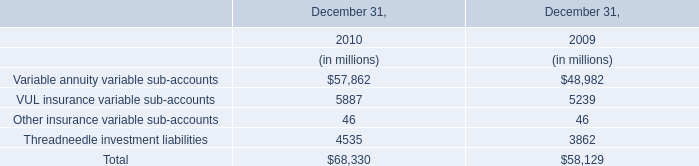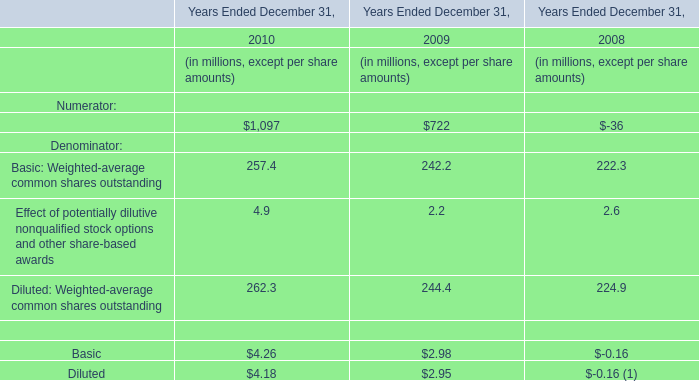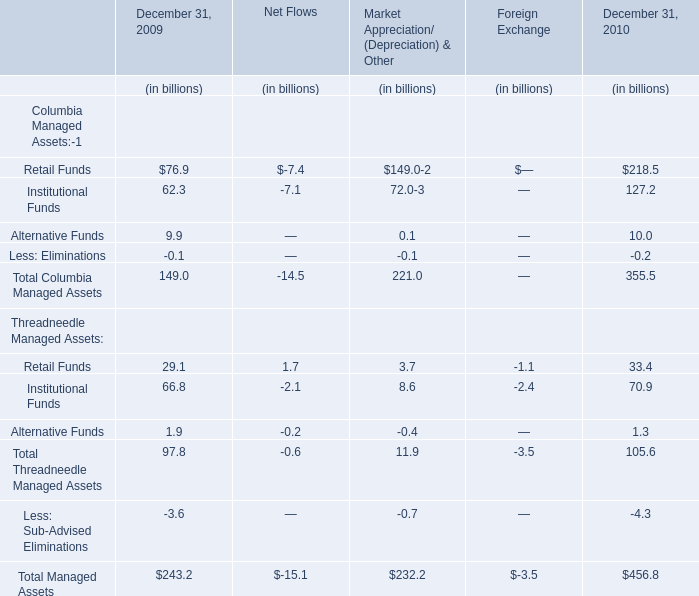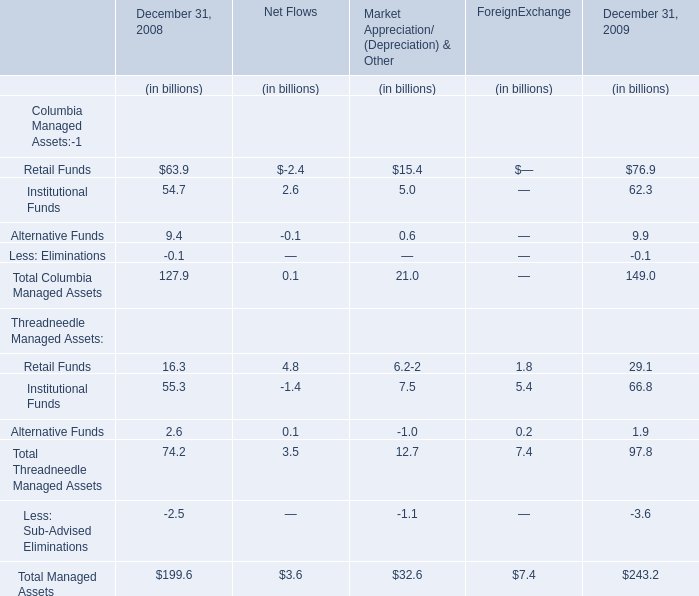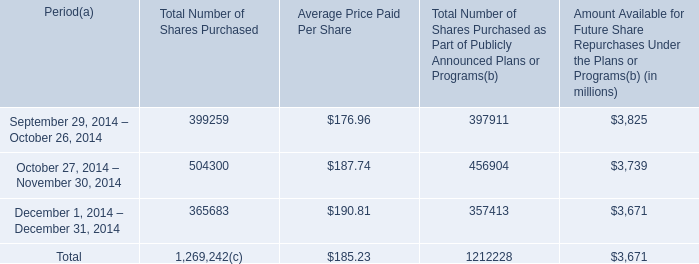What will Total Managed Assets as ended on December 31 reach in 2010 if it continues to grow at its current rate? (in dollars in billions) 
Computations: (243.2 * (1 + ((243.2 - 199.6) / 199.6)))
Answer: 296.32385. 